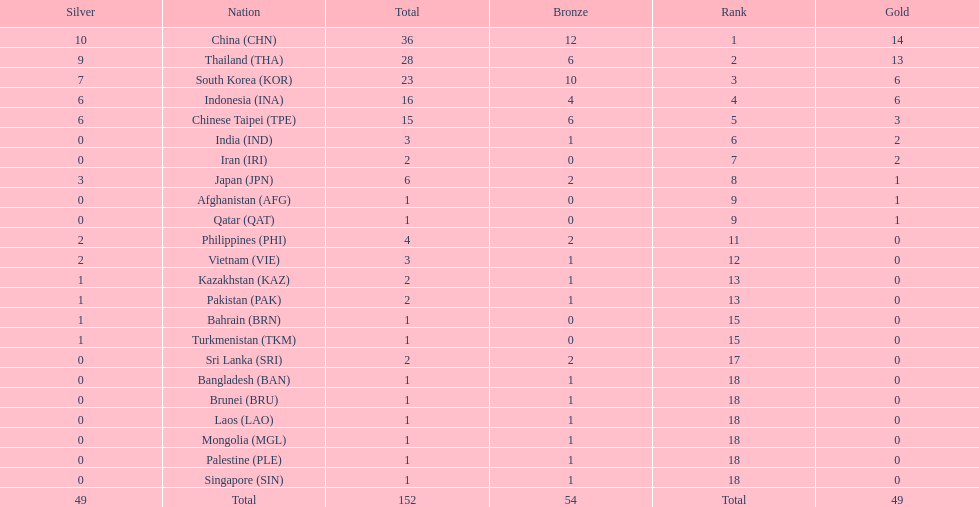What is the total number of nations that participated in the beach games of 2012? 23. 